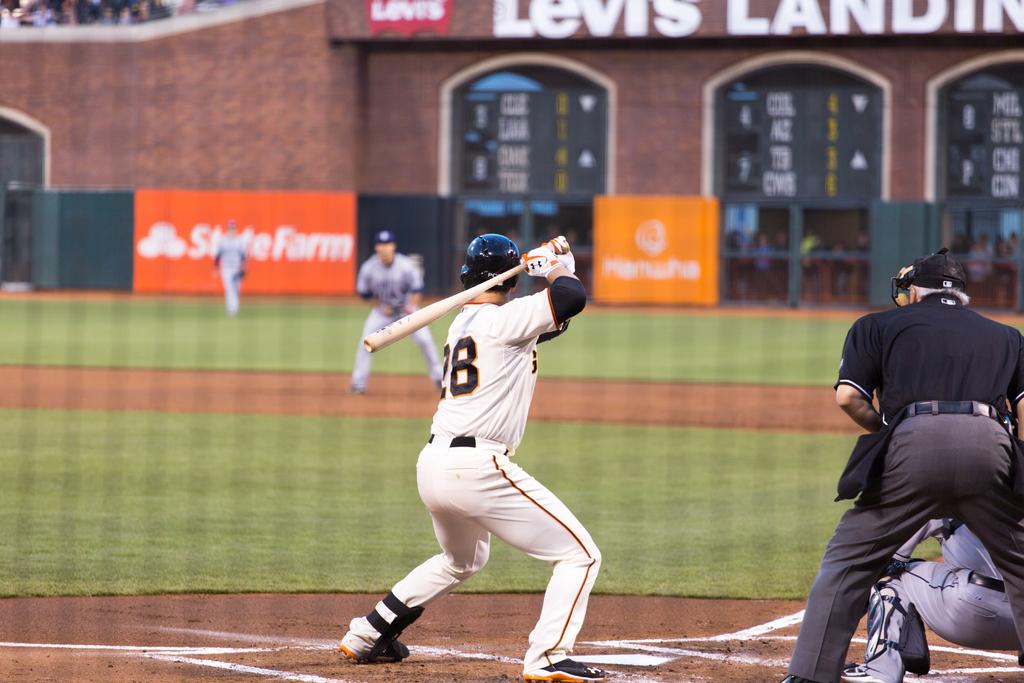What brand is on the back brick wall?
Provide a succinct answer. Levis. 